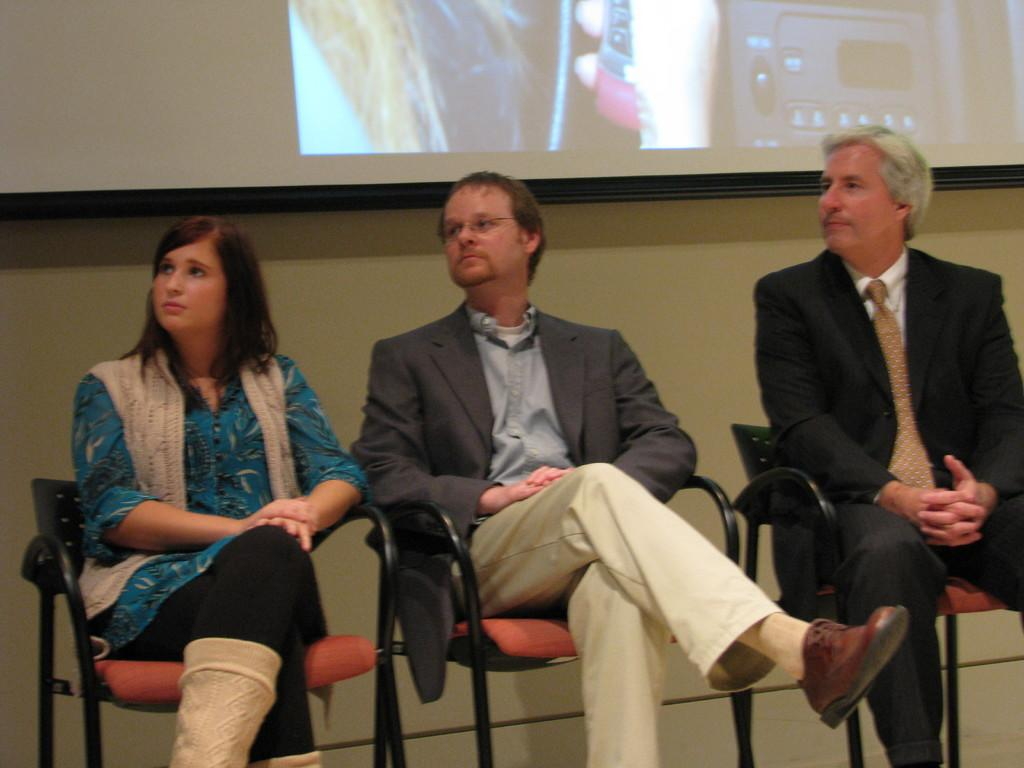How many people are in the image? There are three persons in the image. What are the persons doing in the image? The persons are sitting on chairs. What can be seen in the background of the image? There is a projector screen and a wall in the background of the image. What type of lettuce is on the jeans of the person in the image? There is no lettuce or jeans present in the image; the persons are sitting on chairs, and no clothing is visible. 